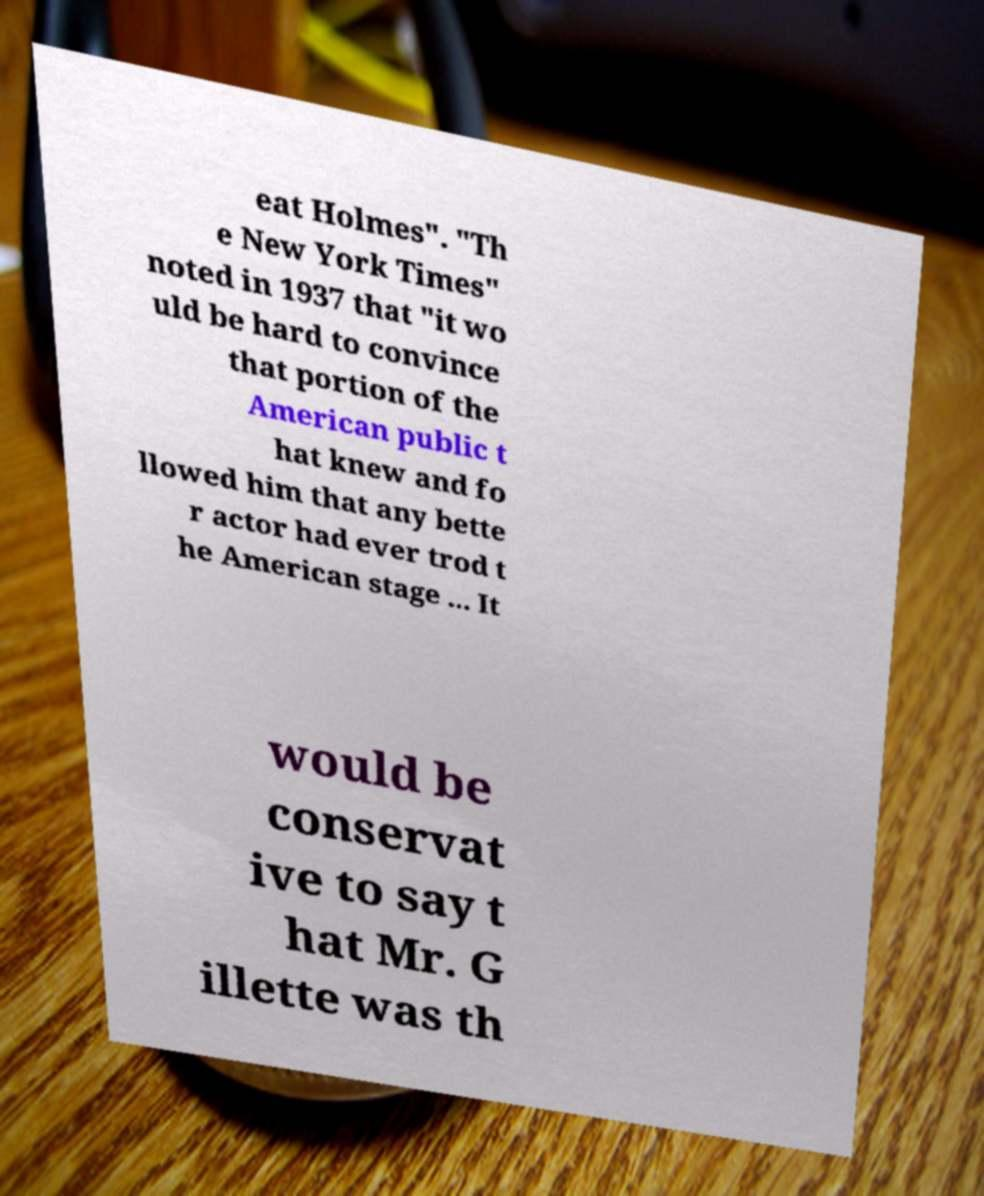Can you accurately transcribe the text from the provided image for me? eat Holmes". "Th e New York Times" noted in 1937 that "it wo uld be hard to convince that portion of the American public t hat knew and fo llowed him that any bette r actor had ever trod t he American stage ... It would be conservat ive to say t hat Mr. G illette was th 